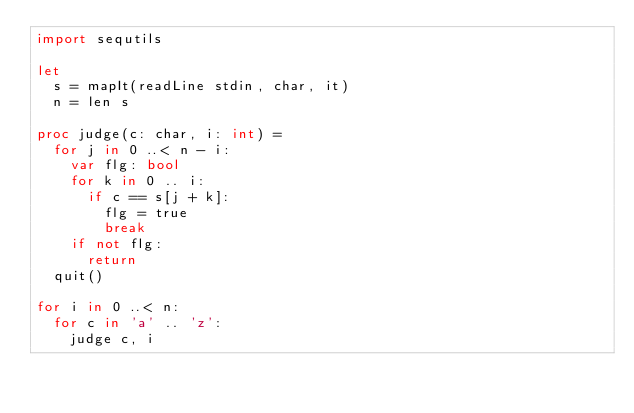Convert code to text. <code><loc_0><loc_0><loc_500><loc_500><_Nim_>import sequtils

let
  s = mapIt(readLine stdin, char, it)
  n = len s

proc judge(c: char, i: int) =
  for j in 0 ..< n - i:
    var flg: bool
    for k in 0 .. i:
      if c == s[j + k]:
        flg = true
        break
    if not flg:
      return
  quit()

for i in 0 ..< n:
  for c in 'a' .. 'z':
    judge c, i
</code> 